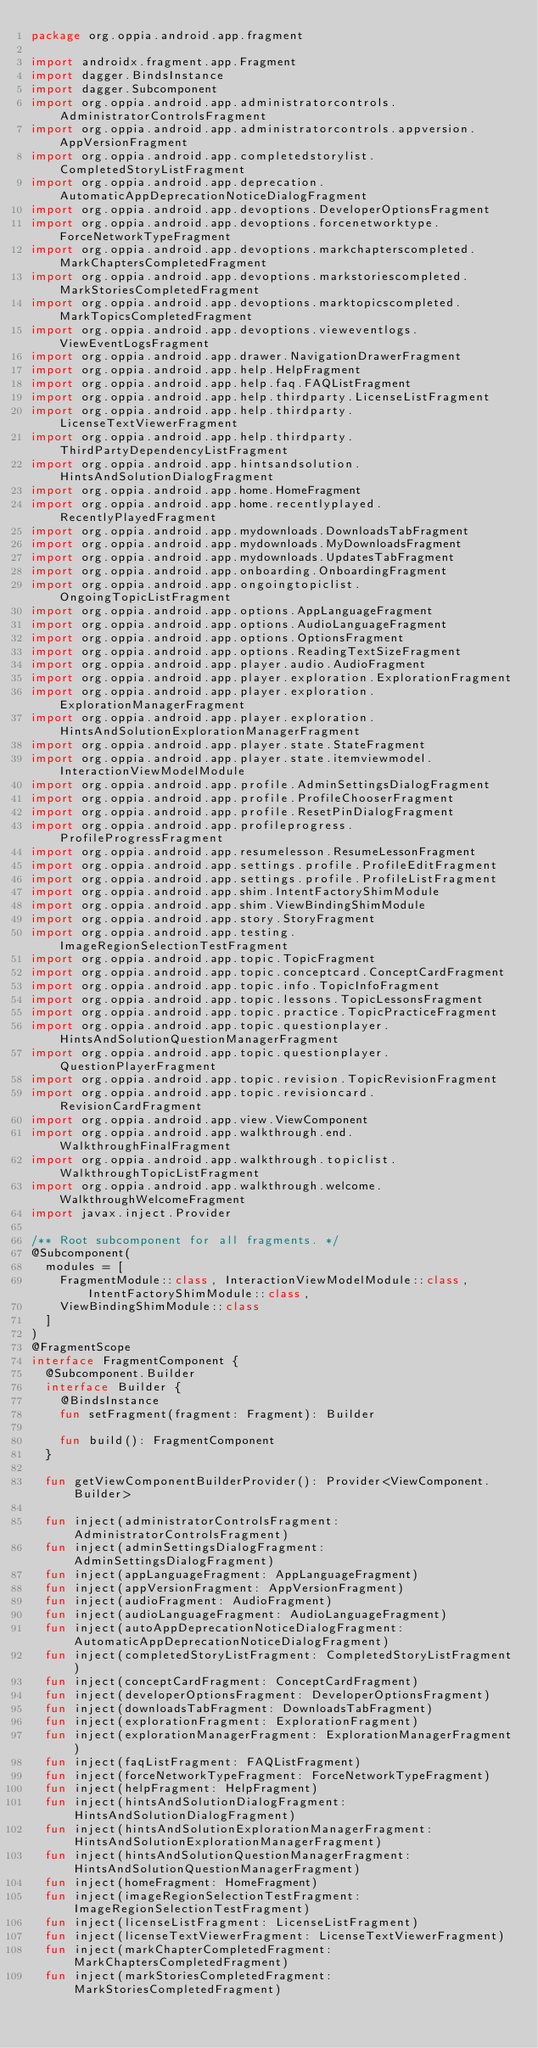Convert code to text. <code><loc_0><loc_0><loc_500><loc_500><_Kotlin_>package org.oppia.android.app.fragment

import androidx.fragment.app.Fragment
import dagger.BindsInstance
import dagger.Subcomponent
import org.oppia.android.app.administratorcontrols.AdministratorControlsFragment
import org.oppia.android.app.administratorcontrols.appversion.AppVersionFragment
import org.oppia.android.app.completedstorylist.CompletedStoryListFragment
import org.oppia.android.app.deprecation.AutomaticAppDeprecationNoticeDialogFragment
import org.oppia.android.app.devoptions.DeveloperOptionsFragment
import org.oppia.android.app.devoptions.forcenetworktype.ForceNetworkTypeFragment
import org.oppia.android.app.devoptions.markchapterscompleted.MarkChaptersCompletedFragment
import org.oppia.android.app.devoptions.markstoriescompleted.MarkStoriesCompletedFragment
import org.oppia.android.app.devoptions.marktopicscompleted.MarkTopicsCompletedFragment
import org.oppia.android.app.devoptions.vieweventlogs.ViewEventLogsFragment
import org.oppia.android.app.drawer.NavigationDrawerFragment
import org.oppia.android.app.help.HelpFragment
import org.oppia.android.app.help.faq.FAQListFragment
import org.oppia.android.app.help.thirdparty.LicenseListFragment
import org.oppia.android.app.help.thirdparty.LicenseTextViewerFragment
import org.oppia.android.app.help.thirdparty.ThirdPartyDependencyListFragment
import org.oppia.android.app.hintsandsolution.HintsAndSolutionDialogFragment
import org.oppia.android.app.home.HomeFragment
import org.oppia.android.app.home.recentlyplayed.RecentlyPlayedFragment
import org.oppia.android.app.mydownloads.DownloadsTabFragment
import org.oppia.android.app.mydownloads.MyDownloadsFragment
import org.oppia.android.app.mydownloads.UpdatesTabFragment
import org.oppia.android.app.onboarding.OnboardingFragment
import org.oppia.android.app.ongoingtopiclist.OngoingTopicListFragment
import org.oppia.android.app.options.AppLanguageFragment
import org.oppia.android.app.options.AudioLanguageFragment
import org.oppia.android.app.options.OptionsFragment
import org.oppia.android.app.options.ReadingTextSizeFragment
import org.oppia.android.app.player.audio.AudioFragment
import org.oppia.android.app.player.exploration.ExplorationFragment
import org.oppia.android.app.player.exploration.ExplorationManagerFragment
import org.oppia.android.app.player.exploration.HintsAndSolutionExplorationManagerFragment
import org.oppia.android.app.player.state.StateFragment
import org.oppia.android.app.player.state.itemviewmodel.InteractionViewModelModule
import org.oppia.android.app.profile.AdminSettingsDialogFragment
import org.oppia.android.app.profile.ProfileChooserFragment
import org.oppia.android.app.profile.ResetPinDialogFragment
import org.oppia.android.app.profileprogress.ProfileProgressFragment
import org.oppia.android.app.resumelesson.ResumeLessonFragment
import org.oppia.android.app.settings.profile.ProfileEditFragment
import org.oppia.android.app.settings.profile.ProfileListFragment
import org.oppia.android.app.shim.IntentFactoryShimModule
import org.oppia.android.app.shim.ViewBindingShimModule
import org.oppia.android.app.story.StoryFragment
import org.oppia.android.app.testing.ImageRegionSelectionTestFragment
import org.oppia.android.app.topic.TopicFragment
import org.oppia.android.app.topic.conceptcard.ConceptCardFragment
import org.oppia.android.app.topic.info.TopicInfoFragment
import org.oppia.android.app.topic.lessons.TopicLessonsFragment
import org.oppia.android.app.topic.practice.TopicPracticeFragment
import org.oppia.android.app.topic.questionplayer.HintsAndSolutionQuestionManagerFragment
import org.oppia.android.app.topic.questionplayer.QuestionPlayerFragment
import org.oppia.android.app.topic.revision.TopicRevisionFragment
import org.oppia.android.app.topic.revisioncard.RevisionCardFragment
import org.oppia.android.app.view.ViewComponent
import org.oppia.android.app.walkthrough.end.WalkthroughFinalFragment
import org.oppia.android.app.walkthrough.topiclist.WalkthroughTopicListFragment
import org.oppia.android.app.walkthrough.welcome.WalkthroughWelcomeFragment
import javax.inject.Provider

/** Root subcomponent for all fragments. */
@Subcomponent(
  modules = [
    FragmentModule::class, InteractionViewModelModule::class, IntentFactoryShimModule::class,
    ViewBindingShimModule::class
  ]
)
@FragmentScope
interface FragmentComponent {
  @Subcomponent.Builder
  interface Builder {
    @BindsInstance
    fun setFragment(fragment: Fragment): Builder

    fun build(): FragmentComponent
  }

  fun getViewComponentBuilderProvider(): Provider<ViewComponent.Builder>

  fun inject(administratorControlsFragment: AdministratorControlsFragment)
  fun inject(adminSettingsDialogFragment: AdminSettingsDialogFragment)
  fun inject(appLanguageFragment: AppLanguageFragment)
  fun inject(appVersionFragment: AppVersionFragment)
  fun inject(audioFragment: AudioFragment)
  fun inject(audioLanguageFragment: AudioLanguageFragment)
  fun inject(autoAppDeprecationNoticeDialogFragment: AutomaticAppDeprecationNoticeDialogFragment)
  fun inject(completedStoryListFragment: CompletedStoryListFragment)
  fun inject(conceptCardFragment: ConceptCardFragment)
  fun inject(developerOptionsFragment: DeveloperOptionsFragment)
  fun inject(downloadsTabFragment: DownloadsTabFragment)
  fun inject(explorationFragment: ExplorationFragment)
  fun inject(explorationManagerFragment: ExplorationManagerFragment)
  fun inject(faqListFragment: FAQListFragment)
  fun inject(forceNetworkTypeFragment: ForceNetworkTypeFragment)
  fun inject(helpFragment: HelpFragment)
  fun inject(hintsAndSolutionDialogFragment: HintsAndSolutionDialogFragment)
  fun inject(hintsAndSolutionExplorationManagerFragment: HintsAndSolutionExplorationManagerFragment)
  fun inject(hintsAndSolutionQuestionManagerFragment: HintsAndSolutionQuestionManagerFragment)
  fun inject(homeFragment: HomeFragment)
  fun inject(imageRegionSelectionTestFragment: ImageRegionSelectionTestFragment)
  fun inject(licenseListFragment: LicenseListFragment)
  fun inject(licenseTextViewerFragment: LicenseTextViewerFragment)
  fun inject(markChapterCompletedFragment: MarkChaptersCompletedFragment)
  fun inject(markStoriesCompletedFragment: MarkStoriesCompletedFragment)</code> 